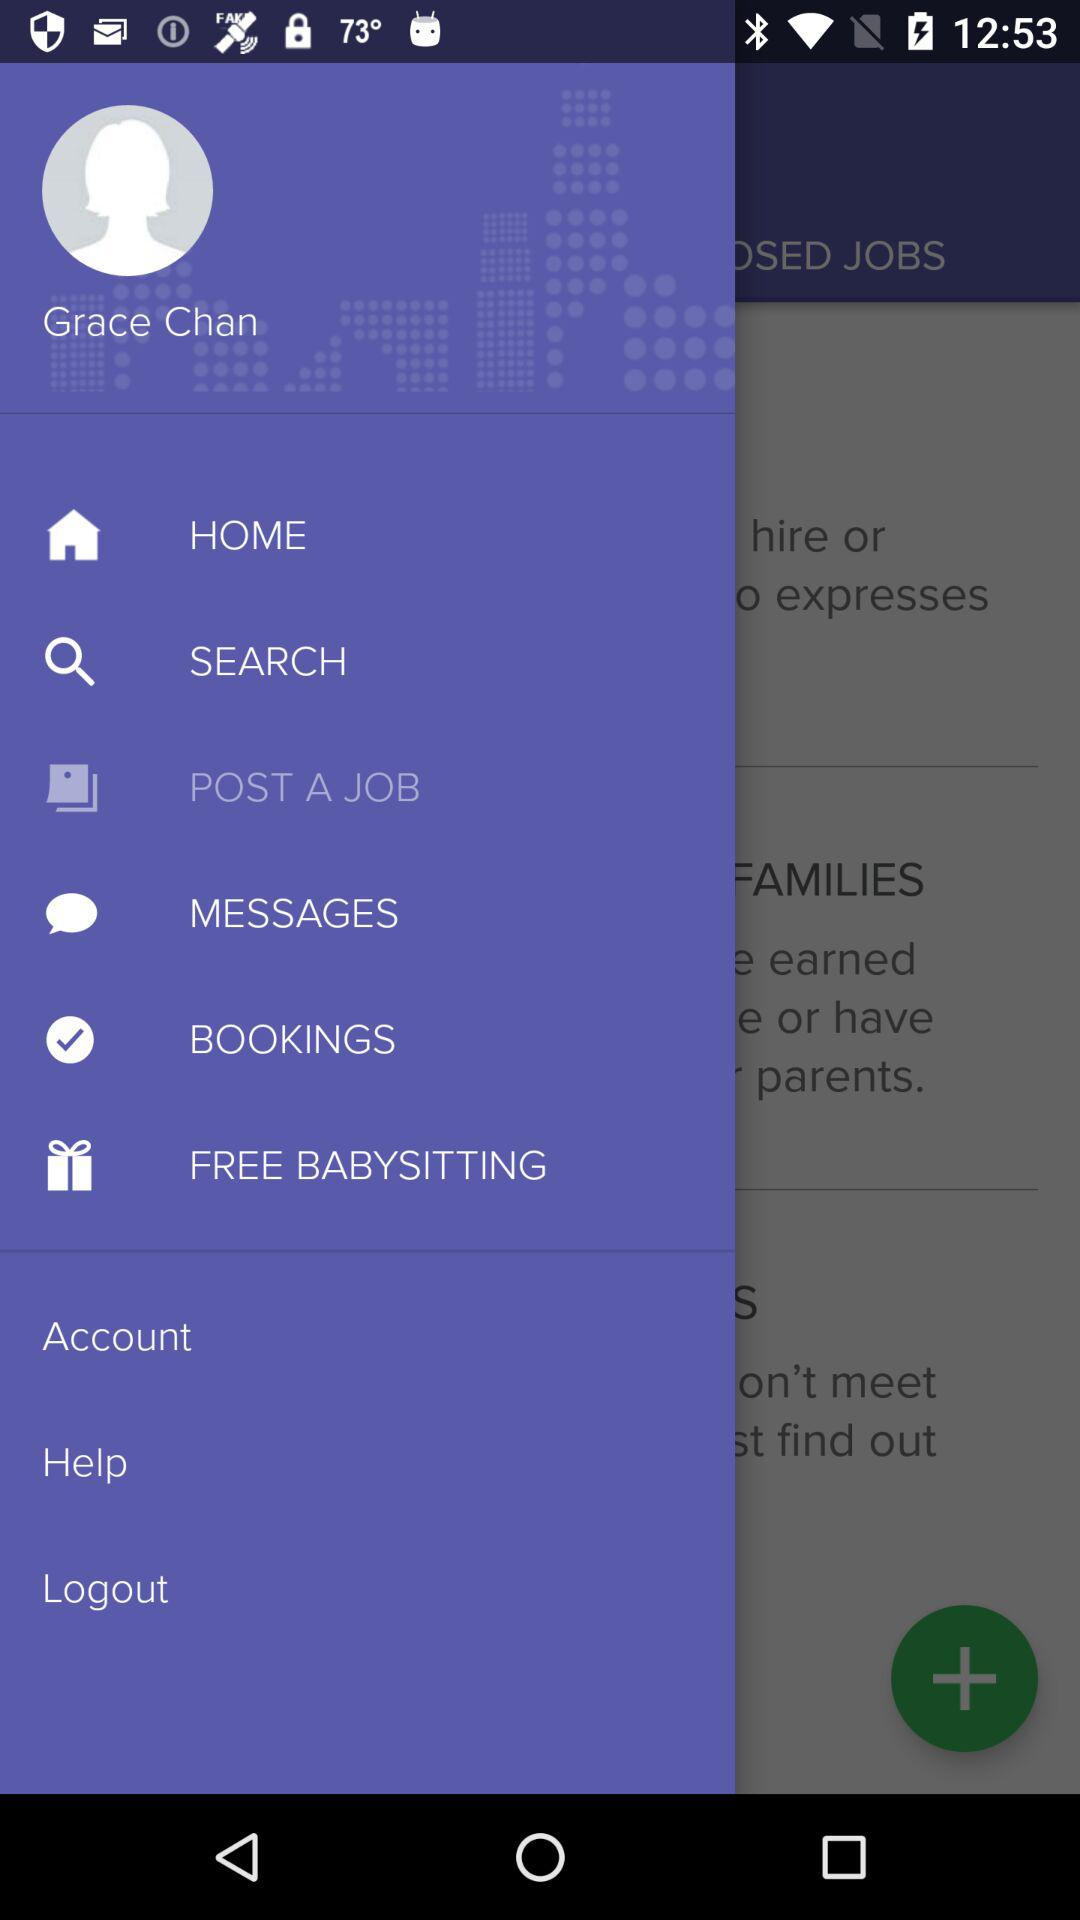What is the name of the user? The name of the user is "Grace Chan". 